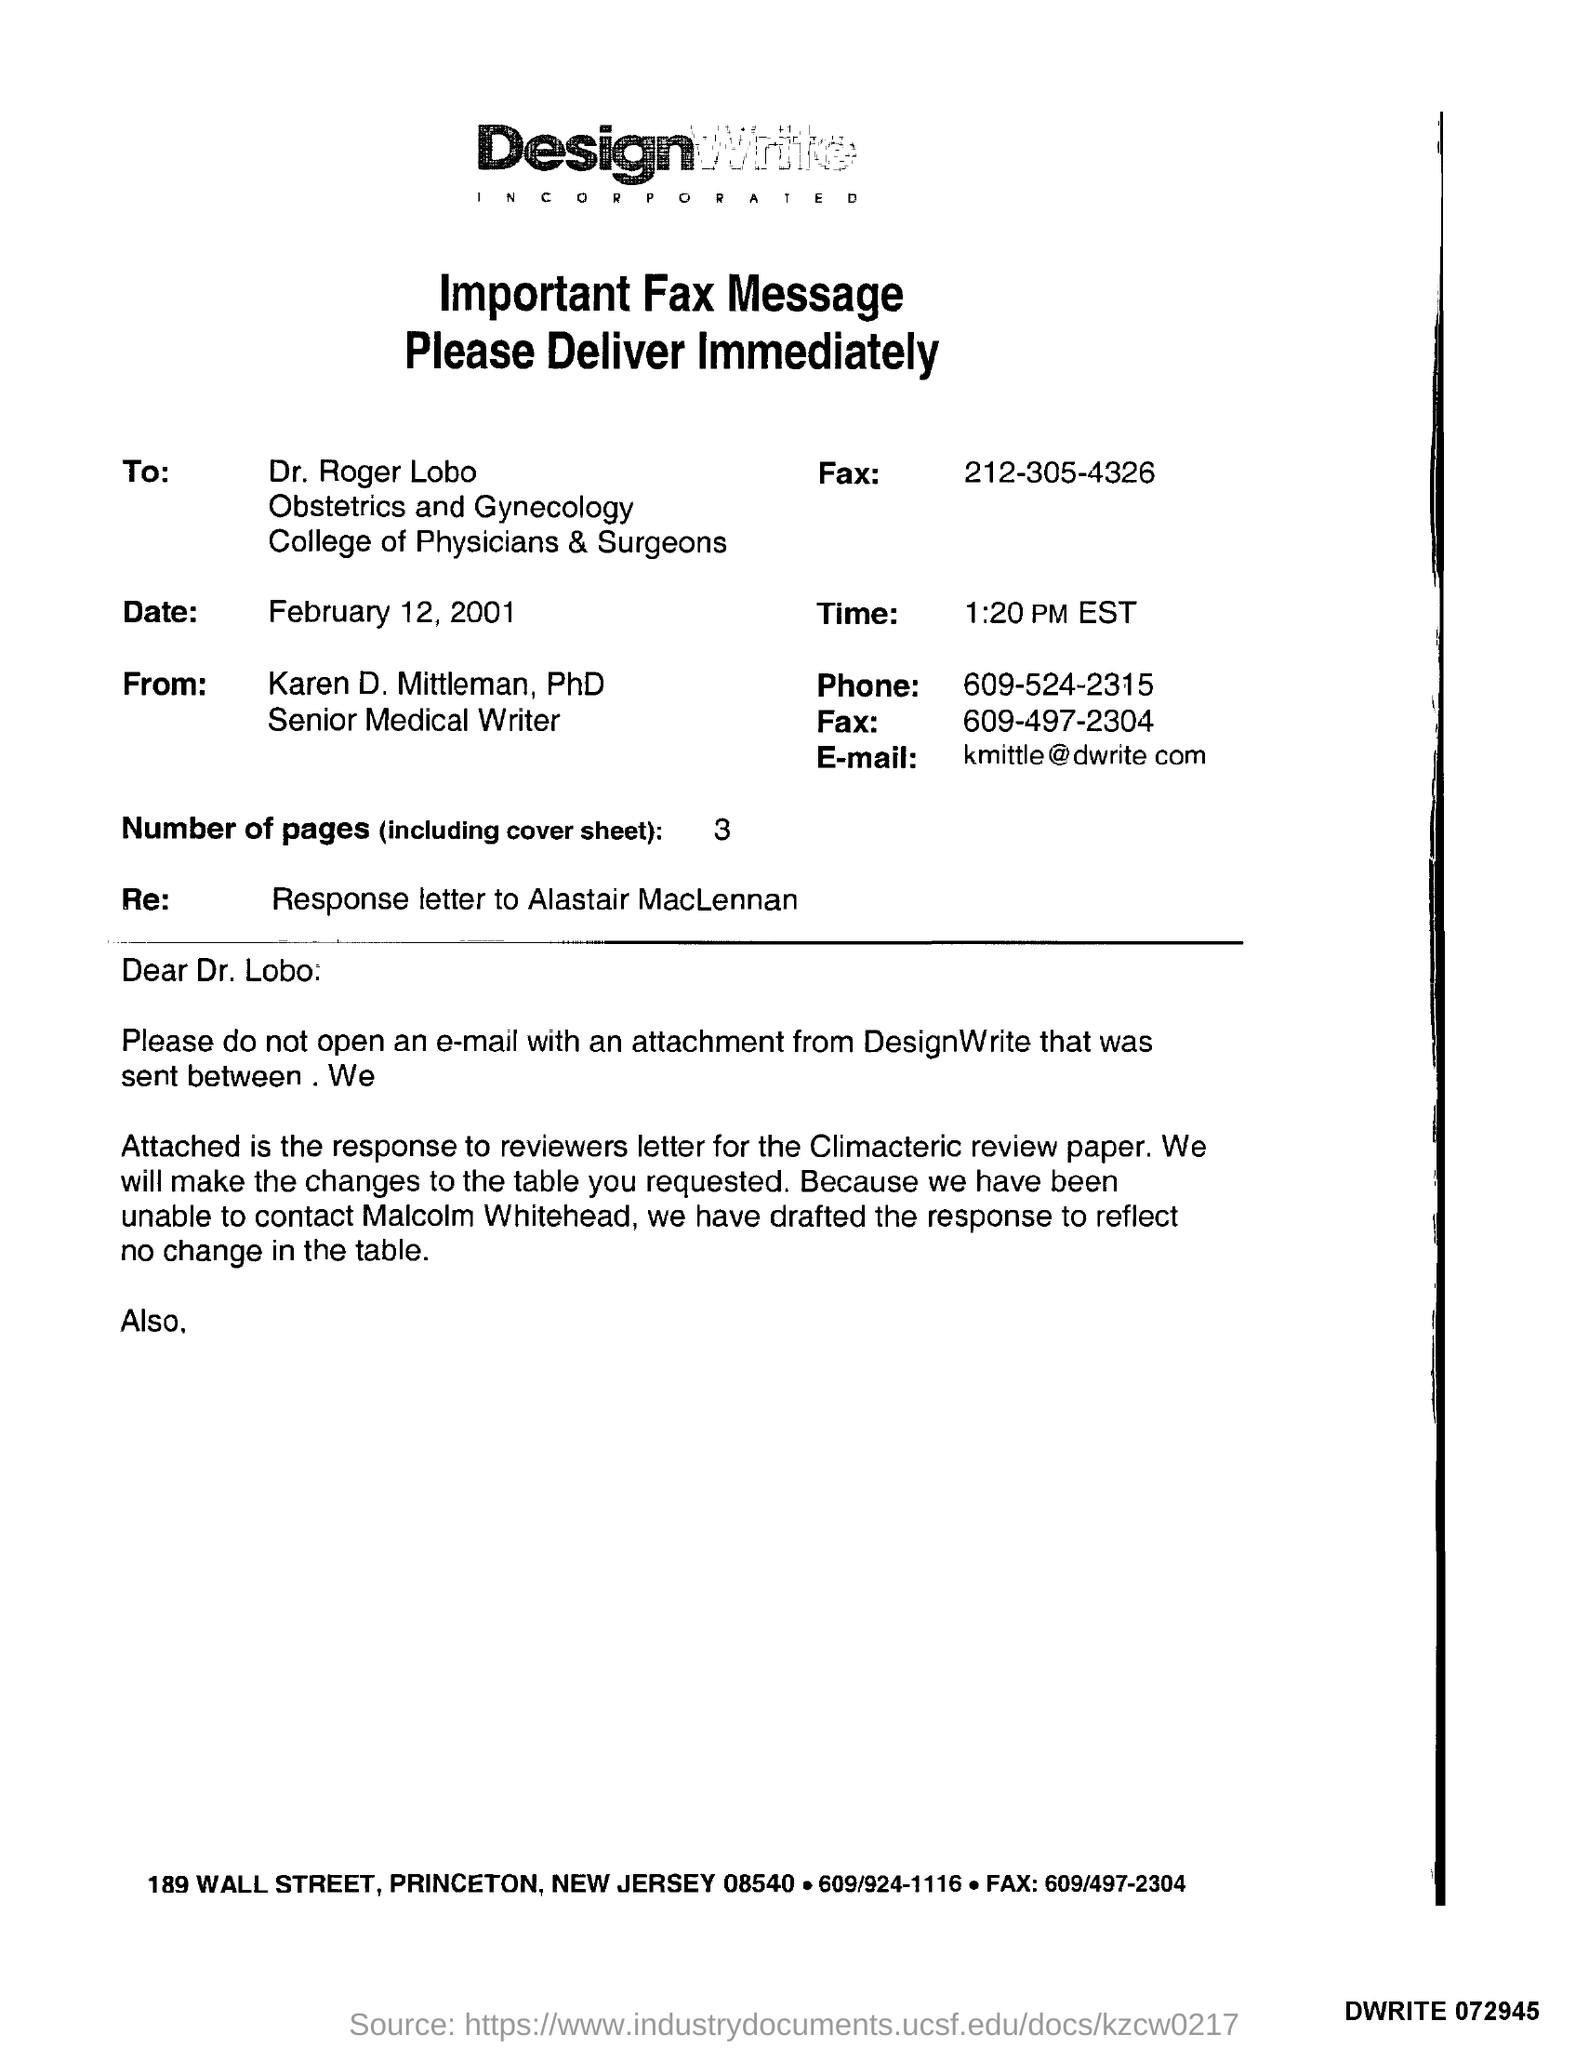Outline some significant characteristics in this image. The salutation of the letter is "Dear Dr. Lobo:...". The number of pages is 3. The e-mail address is [kmittle@dwrite.com](mailto:kmittle@dwrite.com). Now is 1:20 PM EST. 